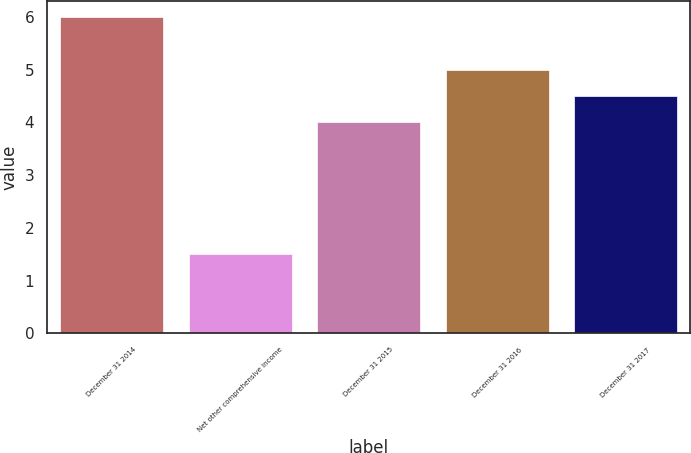<chart> <loc_0><loc_0><loc_500><loc_500><bar_chart><fcel>December 31 2014<fcel>Net other comprehensive income<fcel>December 31 2015<fcel>December 31 2016<fcel>December 31 2017<nl><fcel>6<fcel>1.5<fcel>4<fcel>5<fcel>4.5<nl></chart> 